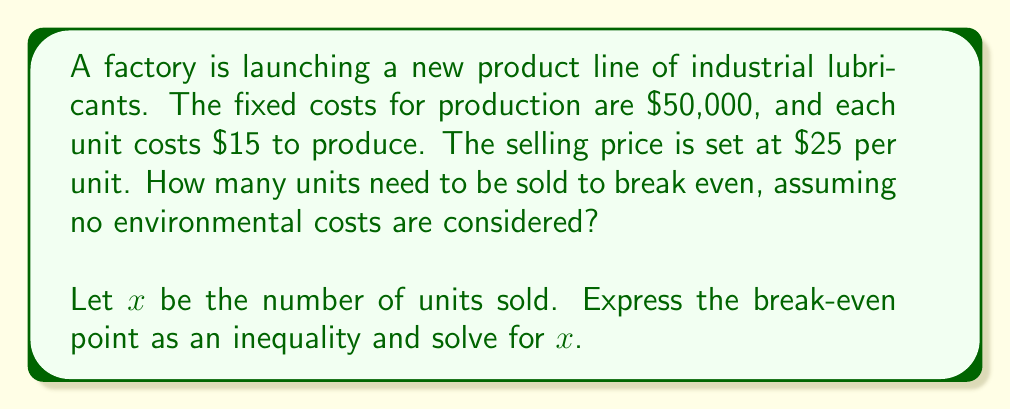What is the answer to this math problem? To solve this problem, we'll follow these steps:

1) Define the break-even point:
   At the break-even point, total revenue equals total costs.

2) Express total revenue:
   Total Revenue = Selling price per unit × Number of units
   $$ TR = 25x $$

3) Express total costs:
   Total Costs = Fixed costs + (Variable cost per unit × Number of units)
   $$ TC = 50000 + 15x $$

4) Set up the break-even inequality:
   Total Revenue ≥ Total Costs
   $$ 25x \geq 50000 + 15x $$

5) Solve the inequality:
   $$ 25x \geq 50000 + 15x $$
   $$ 25x - 15x \geq 50000 $$
   $$ 10x \geq 50000 $$
   $$ x \geq 5000 $$

6) Interpret the result:
   The factory needs to sell at least 5000 units to break even.
Answer: $x \geq 5000$ units 